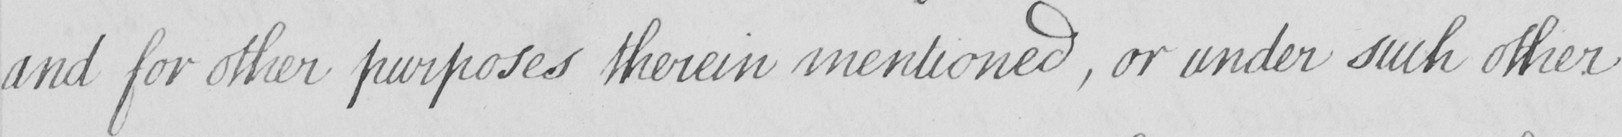What does this handwritten line say? and for other purposes therein mentioned , or under such other 